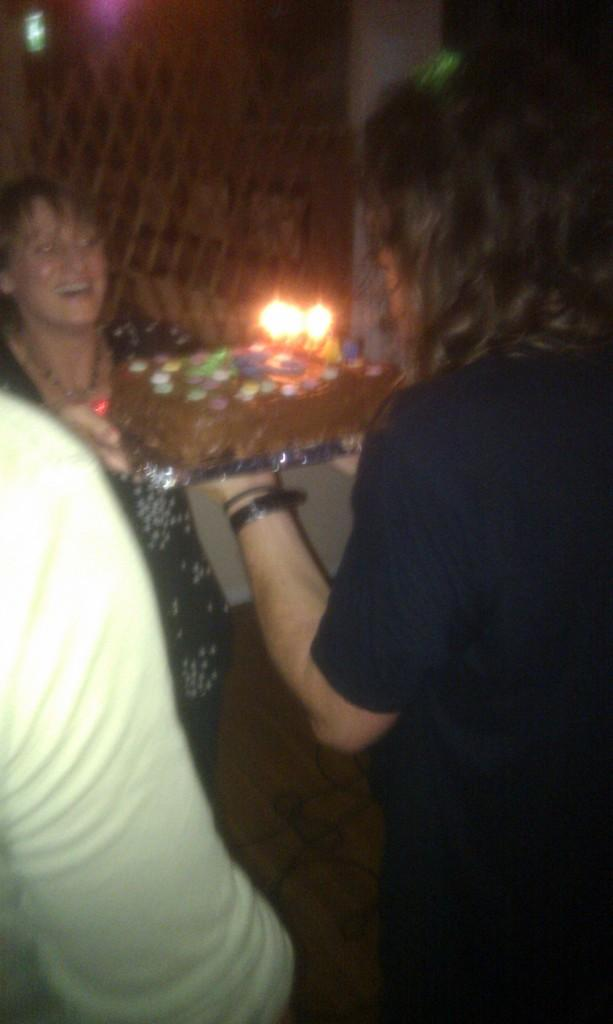What is happening in the image? There are people standing in the image. What can be seen in the background of the image? There are lights and other objects visible in the background of the image. What type of test is being conducted on the road in the image? There is no road or test present in the image; it only shows people standing and objects in the background. 